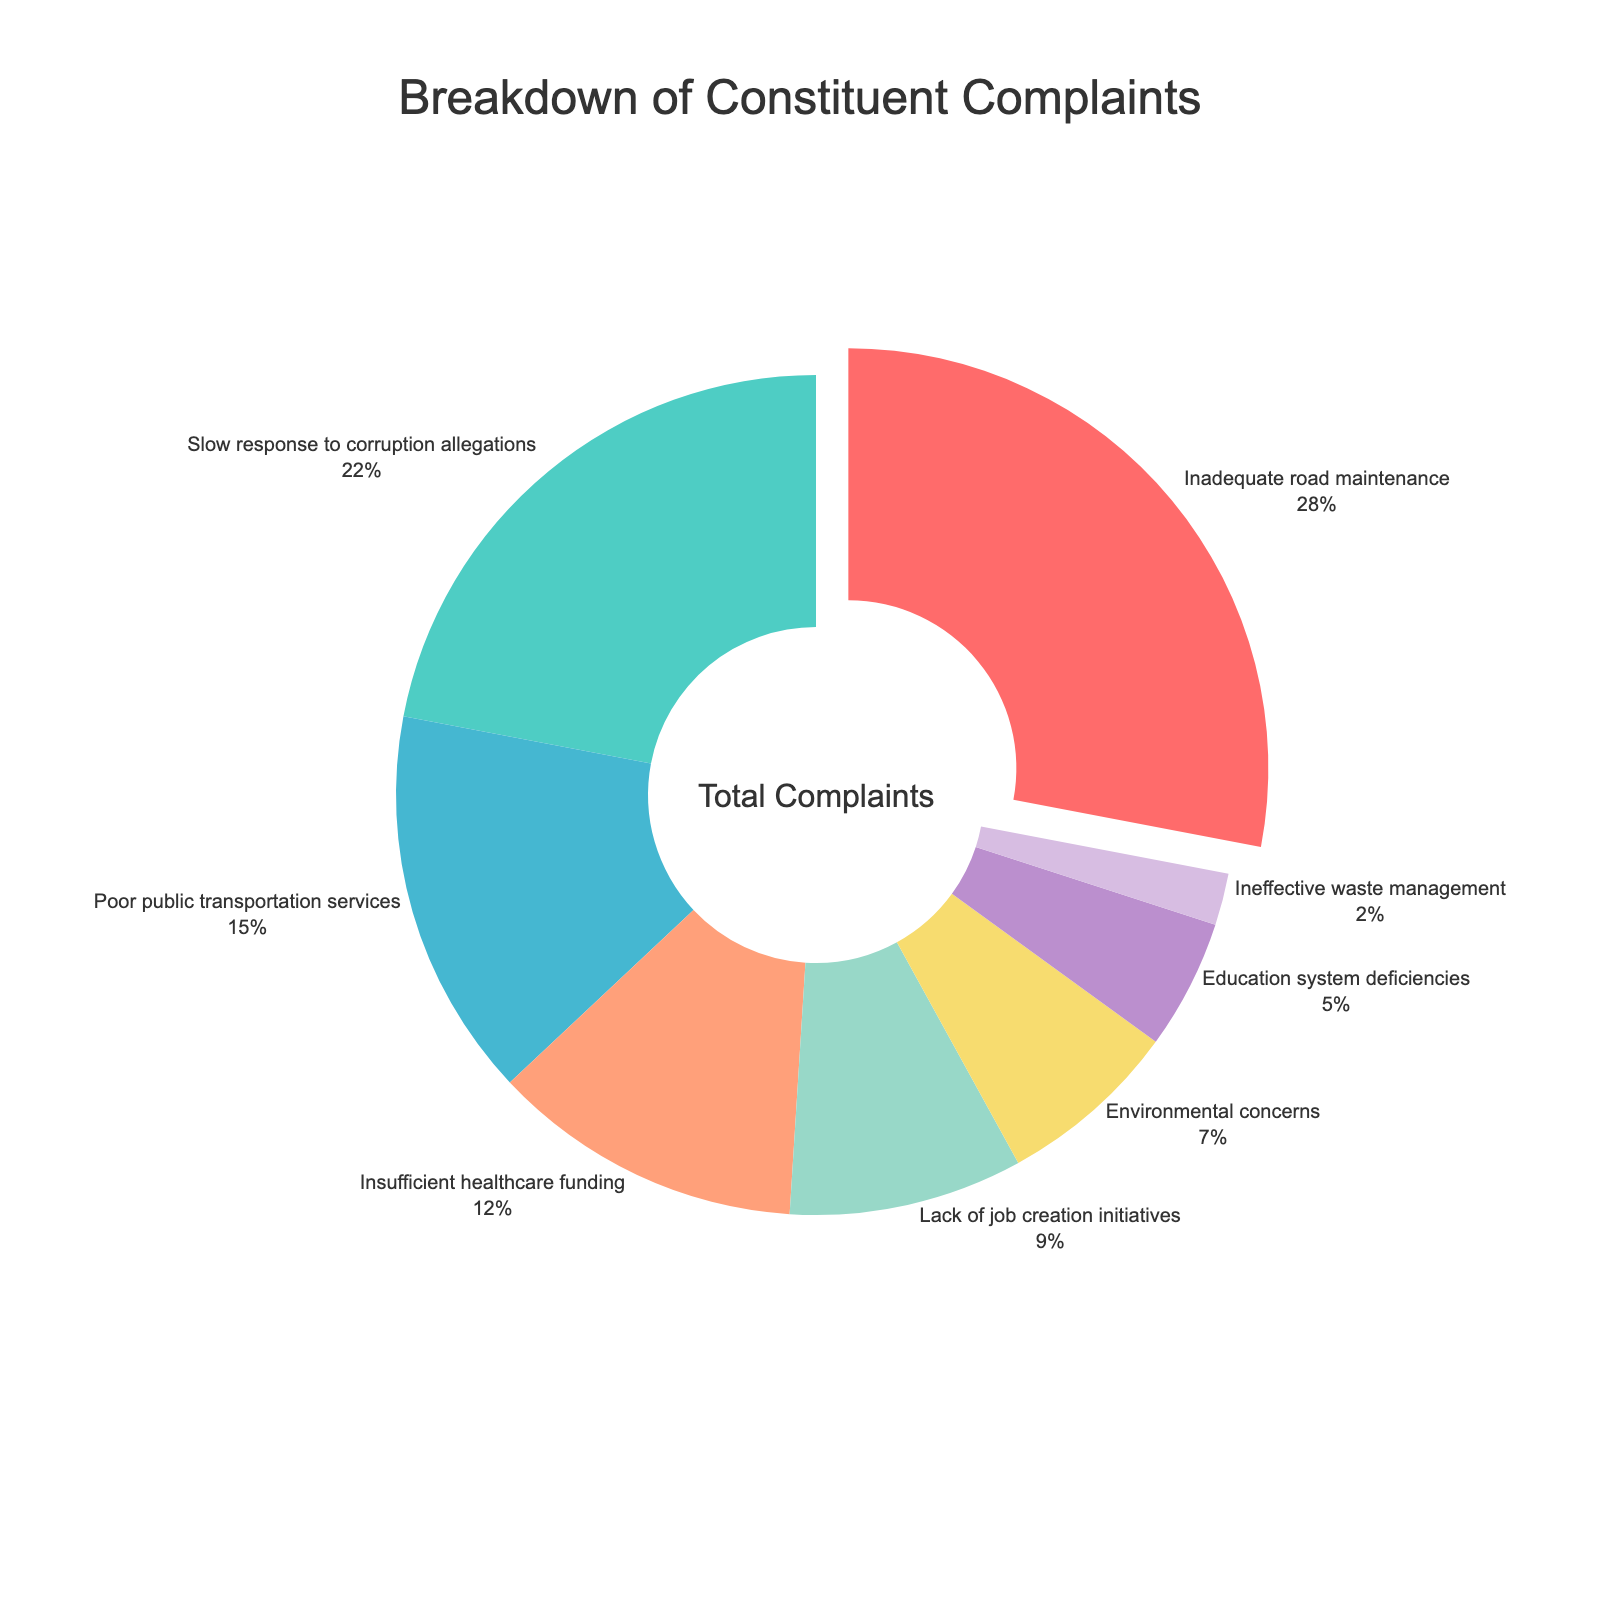What is the percentage of complaints related to inadequate road maintenance? The label for 'Inadequate road maintenance' shows a percentage, which is 28%.
Answer: 28% Which category has the smallest percentage of complaints? The 'Ineffective waste management' category has the smallest slice in the pie chart, which indicates it has the smallest percentage, 2%.
Answer: Ineffective waste management How much greater is the percentage of complaints about inadequate road maintenance compared to education system deficiencies? The percentage for 'Inadequate road maintenance' is 28% and for 'Education system deficiencies' is 5%. The difference is 28% - 5% = 23%.
Answer: 23% Which category is represented by the red color? The color red is associated with the 'Inadequate road maintenance' category in the pie chart.
Answer: Inadequate road maintenance If we combine the percentages of complaints about poor public transportation services and insufficient healthcare funding, what is the total percentage? The percentage for 'Poor public transportation services' is 15% and for 'Insufficient healthcare funding' is 12%. Adding them together, the total percentage is 15% + 12% = 27%.
Answer: 27% How does the percentage of complaints about slow response to corruption allegations compare to that of environmental concerns? The percentage for 'Slow response to corruption allegations' is 22% and for 'Environmental concerns' is 7%. 22% is greater than 7%.
Answer: 22% is greater What is the percentage of complaints against lack of job creation initiatives, and what slice color represents it? The percentage for 'Lack of job creation initiatives' is 9%, and the slice is represented by the light green color.
Answer: 9% and light green Which two categories combined make up the largest portion of complaints? The two largest slices on the pie chart are 'Inadequate road maintenance' at 28% and 'Slow response to corruption allegations' at 22%. Combined, they make up 28% + 22% = 50% of complaints.
Answer: Inadequate road maintenance and Slow response to corruption allegations What proportion of complaints are related to either environmental concerns or ineffective waste management? The percentage for 'Environmental concerns' is 7% and for 'Ineffective waste management' is 2%. Combined, their proportion is 7% + 2% = 9%.
Answer: 9% If the categories with the largest and smallest percentages were swapped, what would be their new percentages in the chart? If 'Inadequate road maintenance' at 28% swapped with 'Ineffective waste management' at 2%, 'Inadequate road maintenance' would be 2% and 'Ineffective waste management' would be 28%.
Answer: 2% for Inadequate road maintenance and 28% for Ineffective waste management 